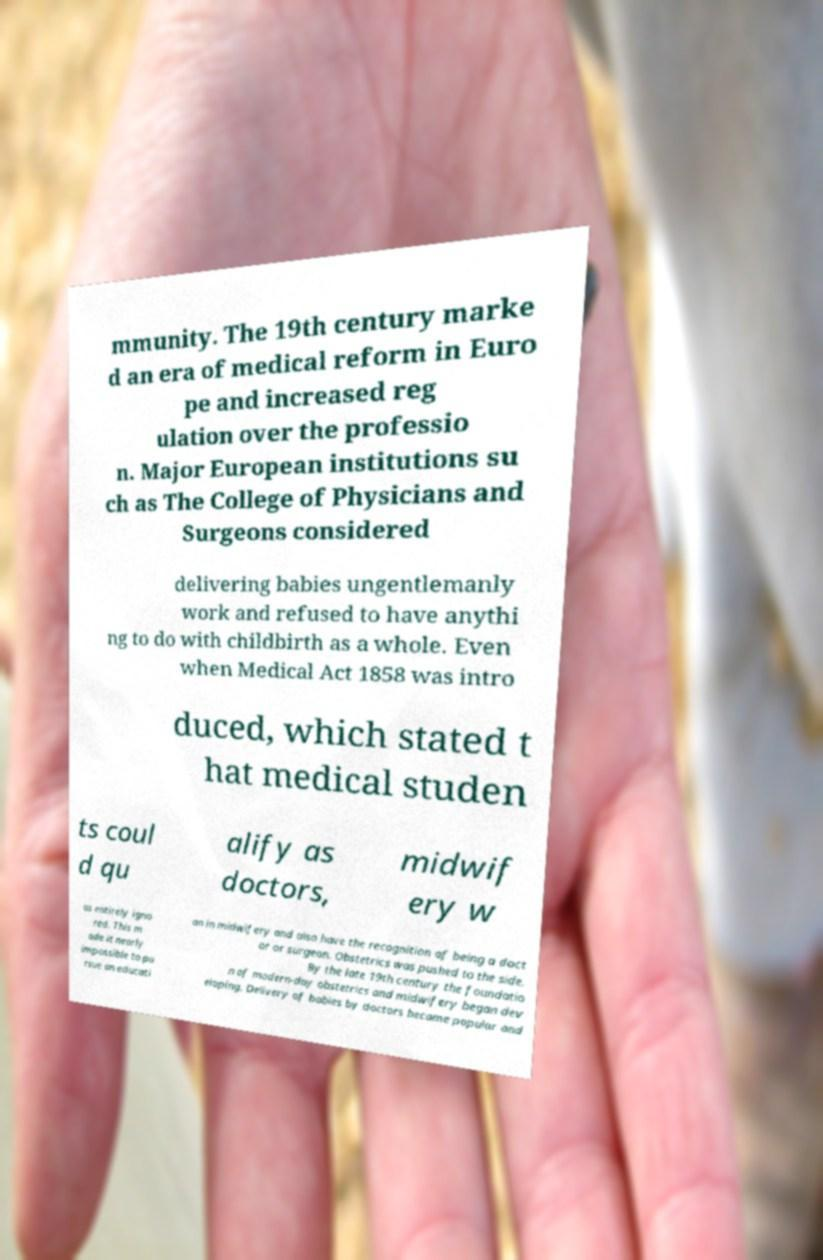Please read and relay the text visible in this image. What does it say? mmunity. The 19th century marke d an era of medical reform in Euro pe and increased reg ulation over the professio n. Major European institutions su ch as The College of Physicians and Surgeons considered delivering babies ungentlemanly work and refused to have anythi ng to do with childbirth as a whole. Even when Medical Act 1858 was intro duced, which stated t hat medical studen ts coul d qu alify as doctors, midwif ery w as entirely igno red. This m ade it nearly impossible to pu rsue an educati on in midwifery and also have the recognition of being a doct or or surgeon. Obstetrics was pushed to the side. By the late 19th century the foundatio n of modern-day obstetrics and midwifery began dev eloping. Delivery of babies by doctors became popular and 